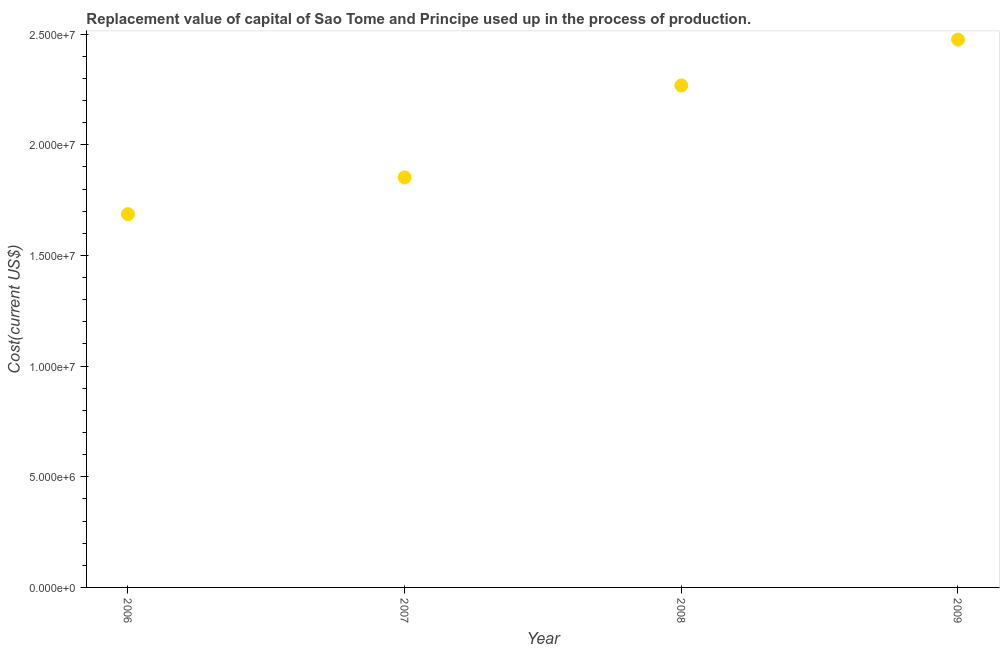What is the consumption of fixed capital in 2007?
Offer a terse response. 1.85e+07. Across all years, what is the maximum consumption of fixed capital?
Give a very brief answer. 2.48e+07. Across all years, what is the minimum consumption of fixed capital?
Offer a terse response. 1.69e+07. What is the sum of the consumption of fixed capital?
Offer a terse response. 8.28e+07. What is the difference between the consumption of fixed capital in 2007 and 2008?
Your answer should be compact. -4.15e+06. What is the average consumption of fixed capital per year?
Ensure brevity in your answer.  2.07e+07. What is the median consumption of fixed capital?
Your answer should be very brief. 2.06e+07. In how many years, is the consumption of fixed capital greater than 4000000 US$?
Your answer should be very brief. 4. What is the ratio of the consumption of fixed capital in 2006 to that in 2009?
Give a very brief answer. 0.68. Is the difference between the consumption of fixed capital in 2006 and 2007 greater than the difference between any two years?
Make the answer very short. No. What is the difference between the highest and the second highest consumption of fixed capital?
Offer a very short reply. 2.07e+06. What is the difference between the highest and the lowest consumption of fixed capital?
Your answer should be very brief. 7.89e+06. How many dotlines are there?
Provide a succinct answer. 1. Does the graph contain grids?
Provide a succinct answer. No. What is the title of the graph?
Make the answer very short. Replacement value of capital of Sao Tome and Principe used up in the process of production. What is the label or title of the X-axis?
Ensure brevity in your answer.  Year. What is the label or title of the Y-axis?
Keep it short and to the point. Cost(current US$). What is the Cost(current US$) in 2006?
Your answer should be very brief. 1.69e+07. What is the Cost(current US$) in 2007?
Give a very brief answer. 1.85e+07. What is the Cost(current US$) in 2008?
Give a very brief answer. 2.27e+07. What is the Cost(current US$) in 2009?
Your answer should be compact. 2.48e+07. What is the difference between the Cost(current US$) in 2006 and 2007?
Your answer should be very brief. -1.66e+06. What is the difference between the Cost(current US$) in 2006 and 2008?
Give a very brief answer. -5.82e+06. What is the difference between the Cost(current US$) in 2006 and 2009?
Keep it short and to the point. -7.89e+06. What is the difference between the Cost(current US$) in 2007 and 2008?
Your answer should be very brief. -4.15e+06. What is the difference between the Cost(current US$) in 2007 and 2009?
Ensure brevity in your answer.  -6.23e+06. What is the difference between the Cost(current US$) in 2008 and 2009?
Provide a succinct answer. -2.07e+06. What is the ratio of the Cost(current US$) in 2006 to that in 2007?
Ensure brevity in your answer.  0.91. What is the ratio of the Cost(current US$) in 2006 to that in 2008?
Provide a short and direct response. 0.74. What is the ratio of the Cost(current US$) in 2006 to that in 2009?
Keep it short and to the point. 0.68. What is the ratio of the Cost(current US$) in 2007 to that in 2008?
Keep it short and to the point. 0.82. What is the ratio of the Cost(current US$) in 2007 to that in 2009?
Give a very brief answer. 0.75. What is the ratio of the Cost(current US$) in 2008 to that in 2009?
Make the answer very short. 0.92. 